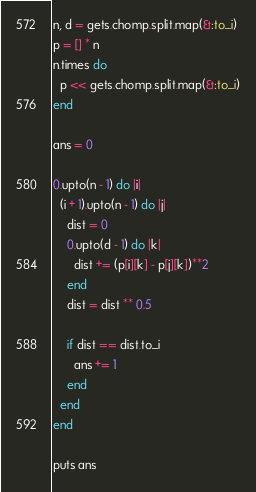Convert code to text. <code><loc_0><loc_0><loc_500><loc_500><_Ruby_>n, d = gets.chomp.split.map(&:to_i)
p = [] * n
n.times do
  p << gets.chomp.split.map(&:to_i)
end

ans = 0

0.upto(n - 1) do |i|
  (i + 1).upto(n - 1) do |j|
    dist = 0
    0.upto(d - 1) do |k|
      dist += (p[i][k] - p[j][k])**2
    end
    dist = dist ** 0.5

    if dist == dist.to_i
      ans += 1
    end
  end
end

puts ans</code> 